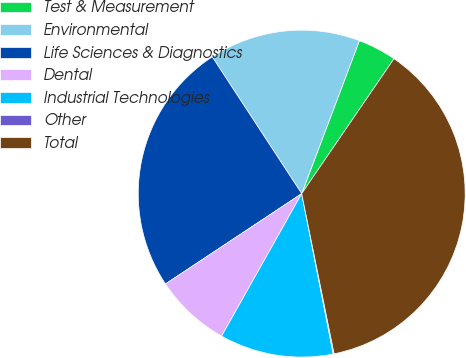<chart> <loc_0><loc_0><loc_500><loc_500><pie_chart><fcel>Test & Measurement<fcel>Environmental<fcel>Life Sciences & Diagnostics<fcel>Dental<fcel>Industrial Technologies<fcel>Other<fcel>Total<nl><fcel>3.81%<fcel>14.96%<fcel>25.1%<fcel>7.53%<fcel>11.24%<fcel>0.09%<fcel>37.27%<nl></chart> 